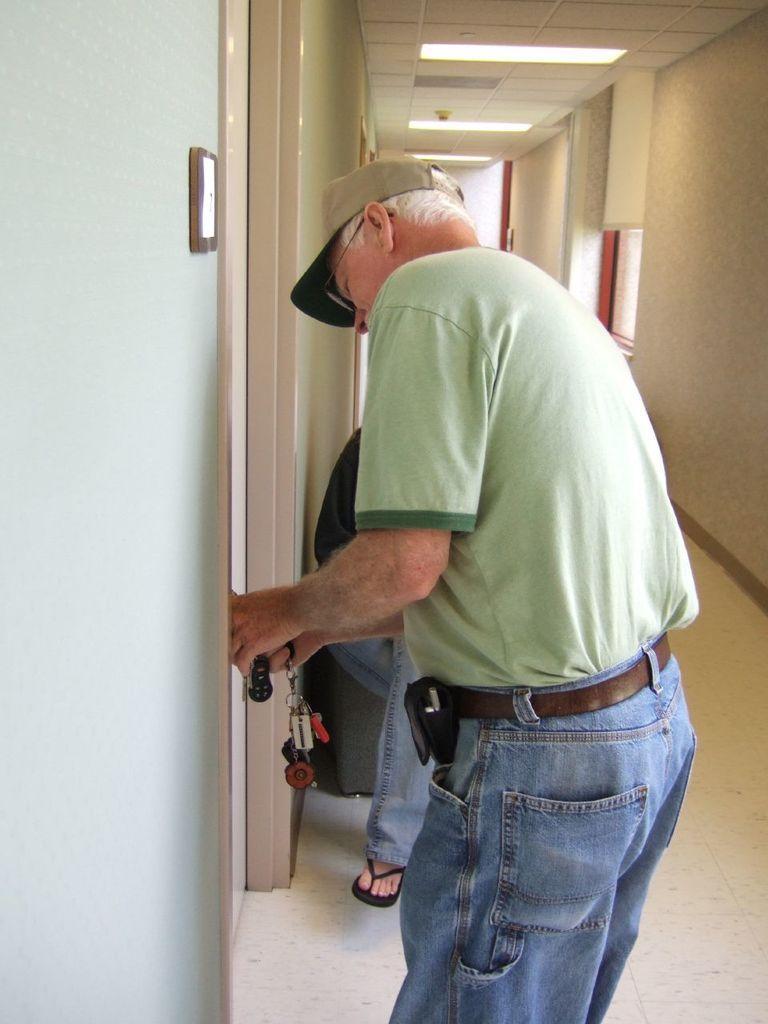Could you give a brief overview of what you see in this image? In this image we can see a man standing on the floor holding the keys and a person sitting beside him. We can also see some doors, a switchboard on a wall and a roof with some ceiling lights. 